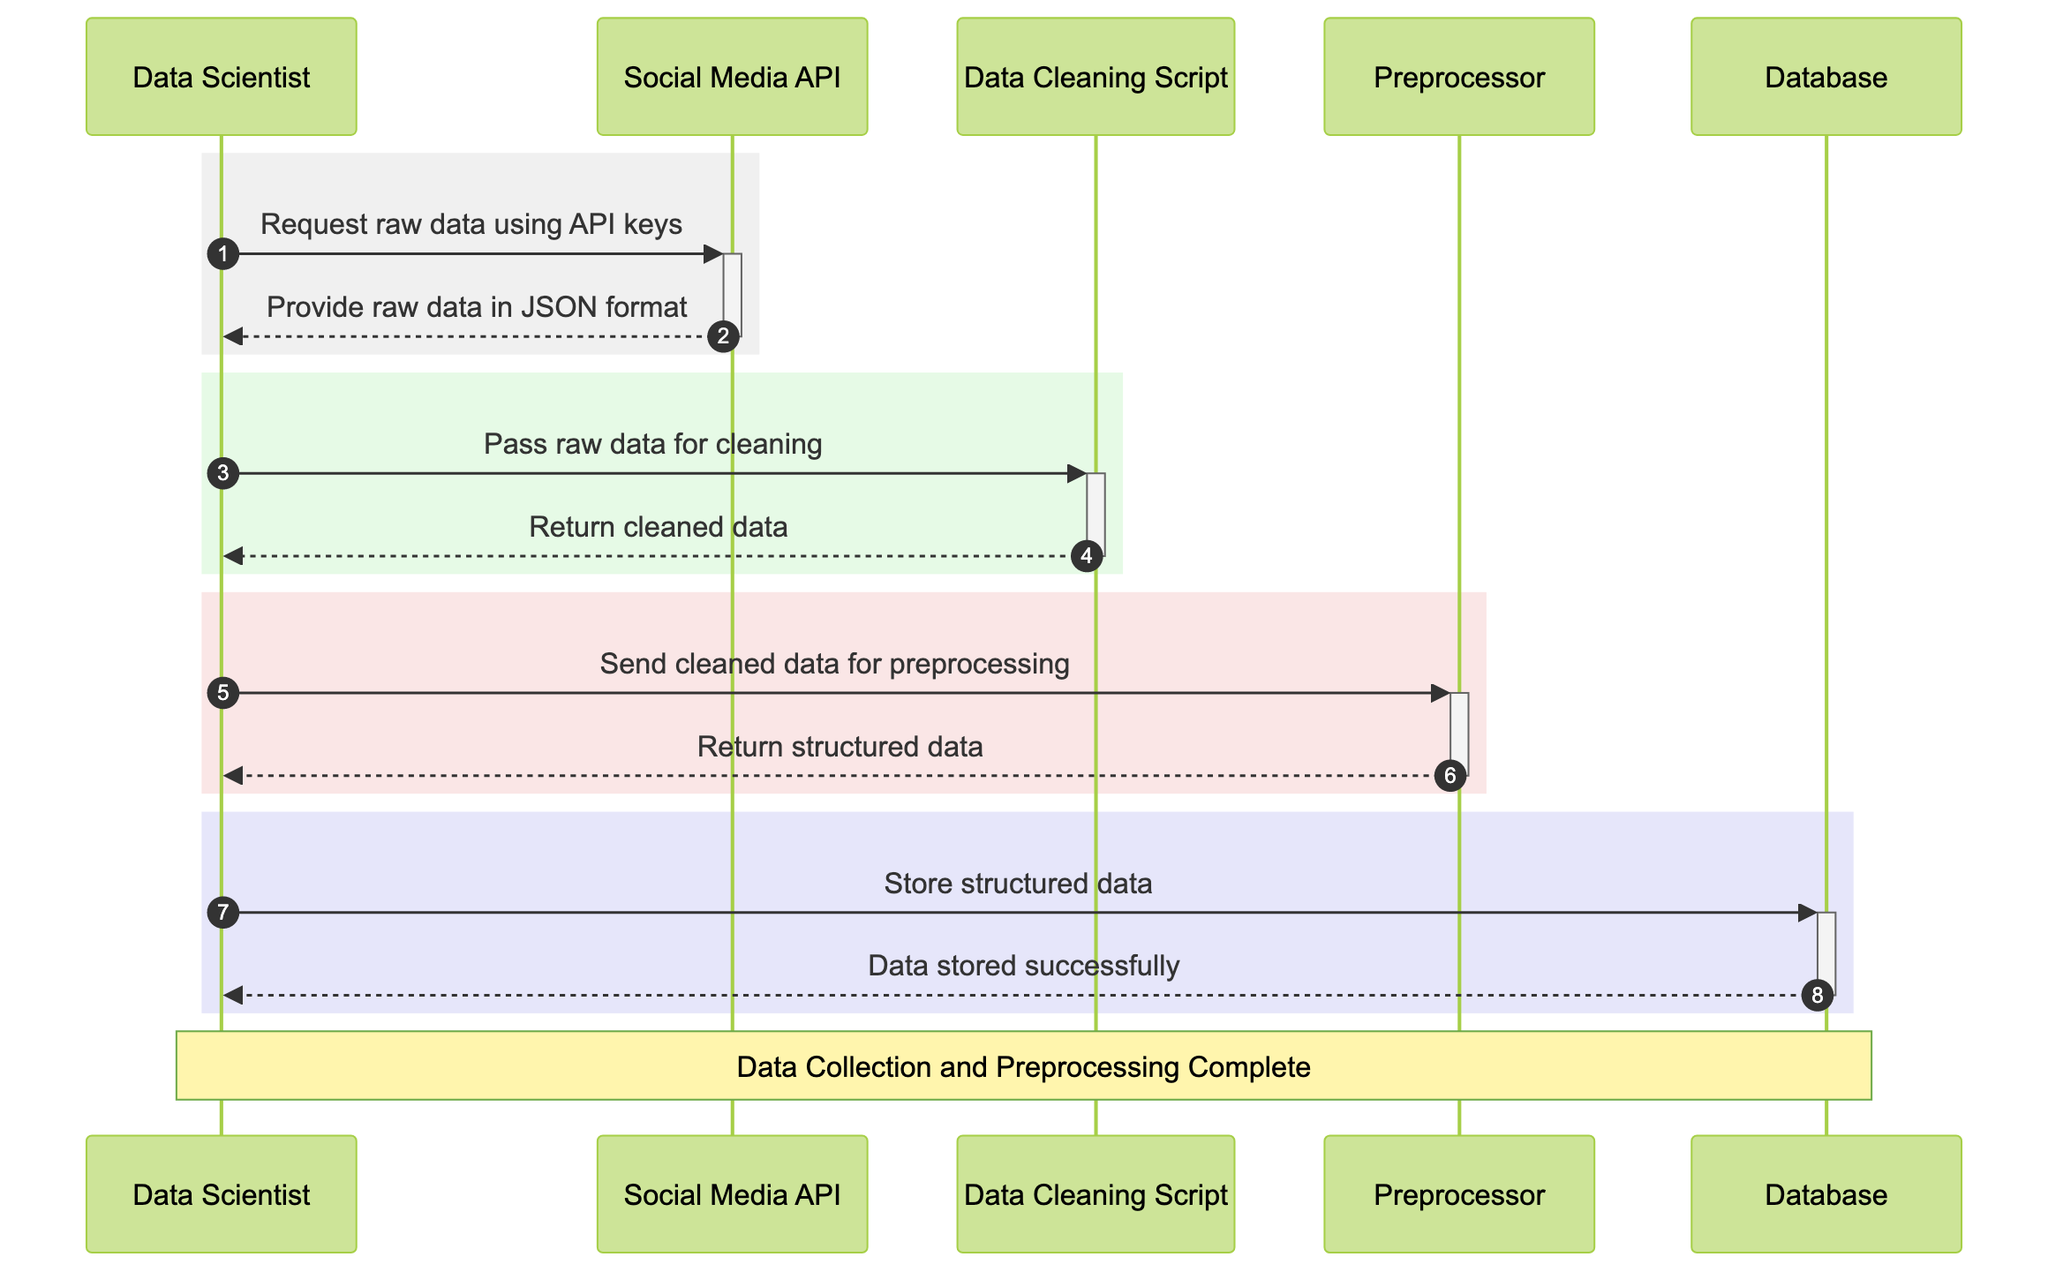What is the first action in the sequence? The first action in the sequence occurs when the Data Scientist requests raw data using API keys from the Social Media API.
Answer: Request raw data using API keys How many actors are in the diagram? The diagram includes five distinct actors participating in the process: Data Scientist, Social Media API, Data Cleaning Script, Preprocessor, and Database.
Answer: Five What does the Social Media API return? The Social Media API provides raw data in JSON format as a response to the Data Scientist's request.
Answer: Provide raw data in JSON format Which actor is responsible for cleaning the raw data? The Data Cleaning Script is the actor designated to remove irrelevant information and correct errors in the raw data.
Answer: Data Cleaning Script What is the final confirmation received by the Data Scientist? The final confirmation received by the Data Scientist is that the data has been stored successfully in the Database.
Answer: Data stored successfully What action precedes the data storage? The action that precedes data storage is the Data Scientist sending the structured data to the Database for storage.
Answer: Send structured data for storage What type of data does the Preprocessor receive? The Preprocessor receives cleaned data from the Data Cleaning Script to transform it into a structured format suitable for analysis.
Answer: Cleaned data How many messages are exchanged between the Data Scientist and the Social Media API? There are two messages exchanged: the request for raw data and the response with raw data in JSON format.
Answer: Two What is the role of the Database in this process? The Database's role is to store the final preprocessed data so it can be used for analysis later on.
Answer: Store the final preprocessed data 